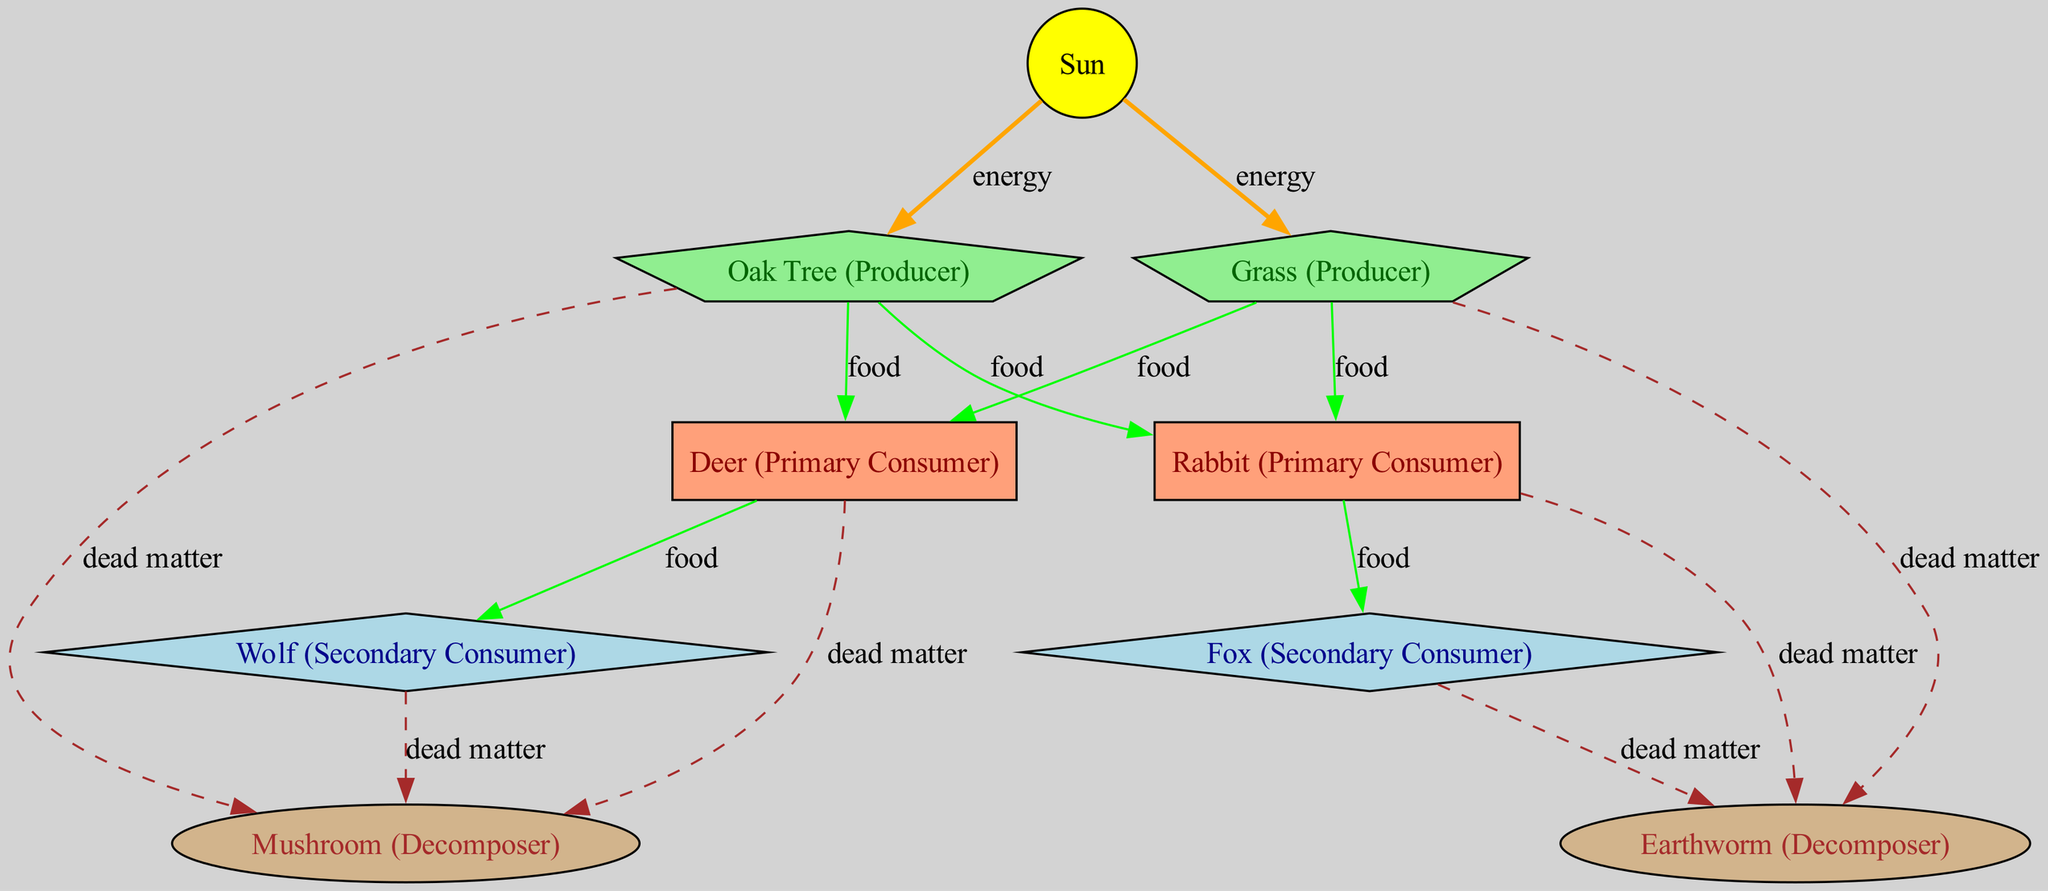What is the primary producer in the forest ecosystem? In the diagram, the primary producer is identified by the node labeled "Oak Tree (Producer)" and is connected to the Sun, which provides energy to it.
Answer: Oak Tree How many primary consumers are present in the food web? The diagram identifies two primary consumers: Deer and Rabbit. By counting the nodes labeled as primary consumers, we find a total of two.
Answer: 2 What type of relationship exists between the Deer and the Wolf? The relationship between Deer and Wolf is labeled as "food" in the diagram. The Deer is a food source for the Wolf, indicating a predator-prey relationship.
Answer: food Which decomposer is associated with the Rabbit? According to the diagram, the Rabbit contributes to the dead matter that the Earthworm decomposes. The Rabbit connects to the Earthworm via a "dead matter" edge.
Answer: Earthworm How many edges are in the food web diagram? By counting all the lines connecting the nodes in the diagram, both direct and indirect relationships, there are a total of 13 edges displayed.
Answer: 13 What do the arrows pointing from the Sun to the Oak Tree and Grass signify? The arrows represent the flow of energy from the Sun to the producers, indicating that these plants utilize sunlight to create energy through photosynthesis.
Answer: energy How many secondary consumers are shown in the diagram? There are two labels for secondary consumers in the diagram: Wolf and Fox. Counting these, we confirm there are two secondary consumers present.
Answer: 2 What kind of matter do decomposers break down in the ecosystem? The diagram illustrates that decomposers break down "dead matter," as seen from the arrows leading from primary and secondary consumers to the decomposers.
Answer: dead matter Which node directly consumes the Oak Tree? The Deer and the Rabbit have arrows connected to the Oak Tree, indicating they consume it. Therefore, both of them are direct consumers of the Oak Tree.
Answer: Deer, Rabbit 